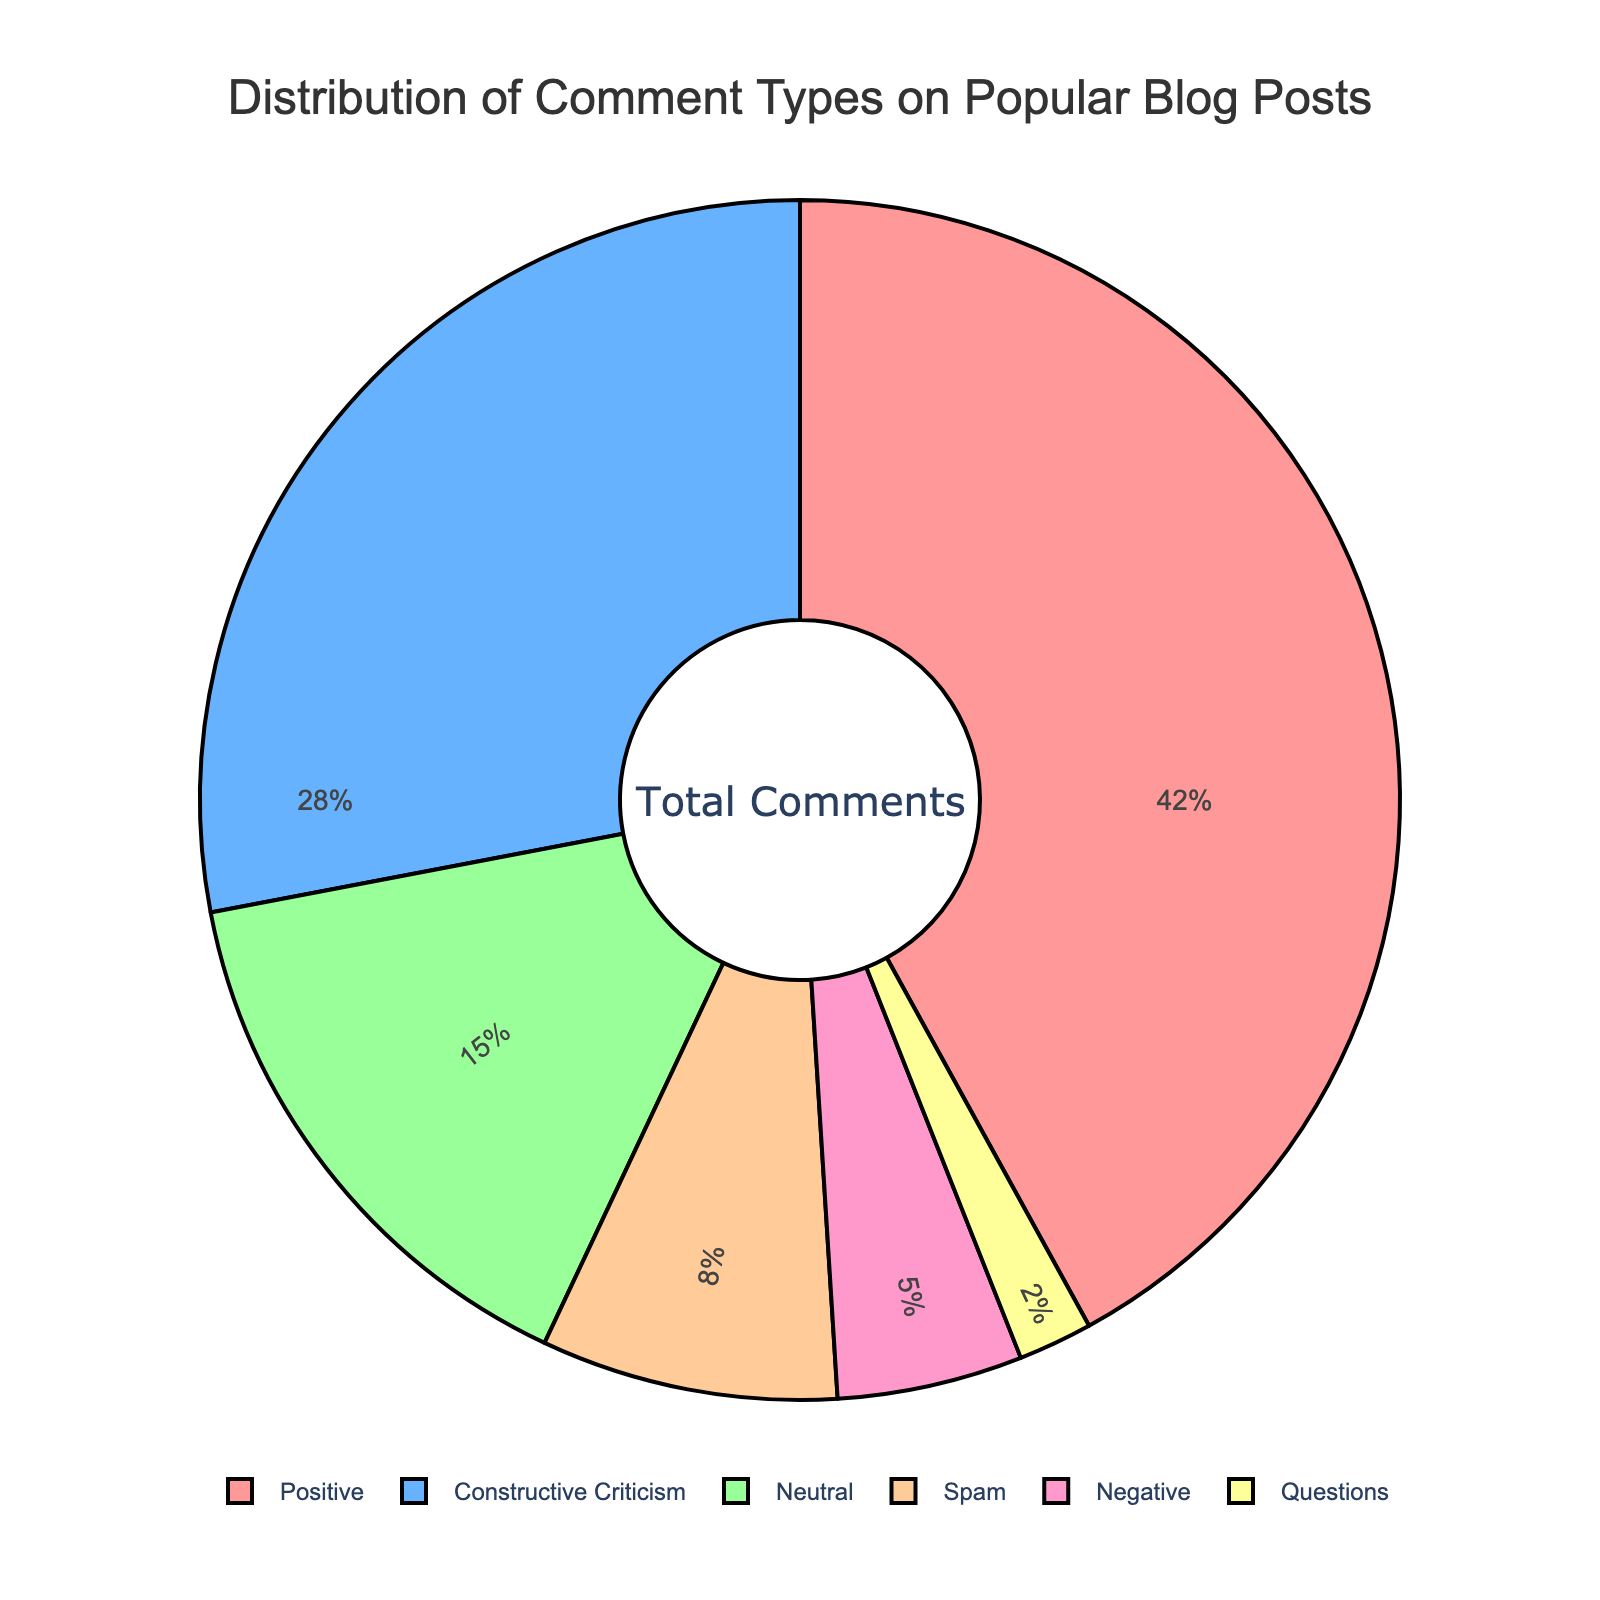Which comment type has the highest percentage? Referring to the pie chart, the biggest section with 42% belongs to the "Positive" comment type.
Answer: Positive What is the combined percentage of constructive criticism and neutral comments? To find the combined percentage, sum up the percentages of constructive criticism (28%) and neutral comments (15%). 28 + 15 = 43%
Answer: 43% How does the percentage of spam comments compare to negative comments? From the chart, the percentage of spam comments (8%) is greater than that of negative comments (5%).
Answer: Spam is greater Among the comment types, which ones have less than 10% representation? From the chart, both "Spam" (8%) and "Negative" (5%) fall under 10%, as well as "Questions" (2%).
Answer: Spam, Negative, Questions What visual characteristic represents the highest comment type? The largest segment in the pie chart, visually noticeable by size which reflects the highest percentage, represents the "Positive" comment type.
Answer: Largest segment If you were to remove spam comments, what would the total percentage of the remaining comments be? Removing spam comments (8%) from the total (100%) leaves the remaining percentage as 100 - 8 = 92%.
Answer: 92% What is the difference in percentage between positive comments and spam comments? The percentage of positive comments is 42% and spam comments is 8%. The difference is calculated as 42 - 8 = 34%.
Answer: 34% How do neutral comments visually contrast with constructive criticism comments in the chart? Neutral comments (15%) occupy a smaller section compared to constructive criticism comments (28%), visually making the neutral section smaller and less dominant.
Answer: Neutral is smaller 